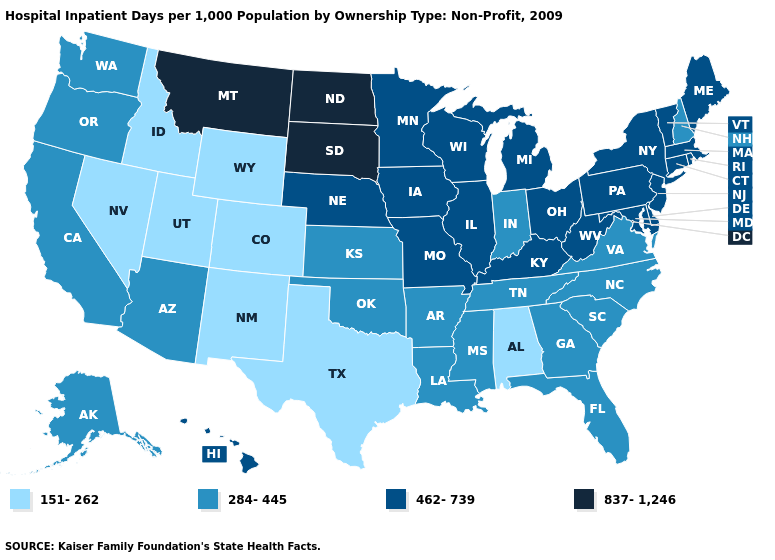Which states have the lowest value in the USA?
Keep it brief. Alabama, Colorado, Idaho, Nevada, New Mexico, Texas, Utah, Wyoming. What is the highest value in the Northeast ?
Be succinct. 462-739. Among the states that border South Dakota , which have the highest value?
Concise answer only. Montana, North Dakota. Name the states that have a value in the range 284-445?
Concise answer only. Alaska, Arizona, Arkansas, California, Florida, Georgia, Indiana, Kansas, Louisiana, Mississippi, New Hampshire, North Carolina, Oklahoma, Oregon, South Carolina, Tennessee, Virginia, Washington. Which states have the lowest value in the South?
Write a very short answer. Alabama, Texas. What is the value of Colorado?
Give a very brief answer. 151-262. What is the value of Georgia?
Be succinct. 284-445. Among the states that border Maine , which have the highest value?
Answer briefly. New Hampshire. Name the states that have a value in the range 837-1,246?
Give a very brief answer. Montana, North Dakota, South Dakota. Name the states that have a value in the range 151-262?
Be succinct. Alabama, Colorado, Idaho, Nevada, New Mexico, Texas, Utah, Wyoming. Is the legend a continuous bar?
Quick response, please. No. Does the map have missing data?
Answer briefly. No. What is the value of Missouri?
Keep it brief. 462-739. Which states have the highest value in the USA?
Answer briefly. Montana, North Dakota, South Dakota. What is the highest value in states that border Nevada?
Give a very brief answer. 284-445. 